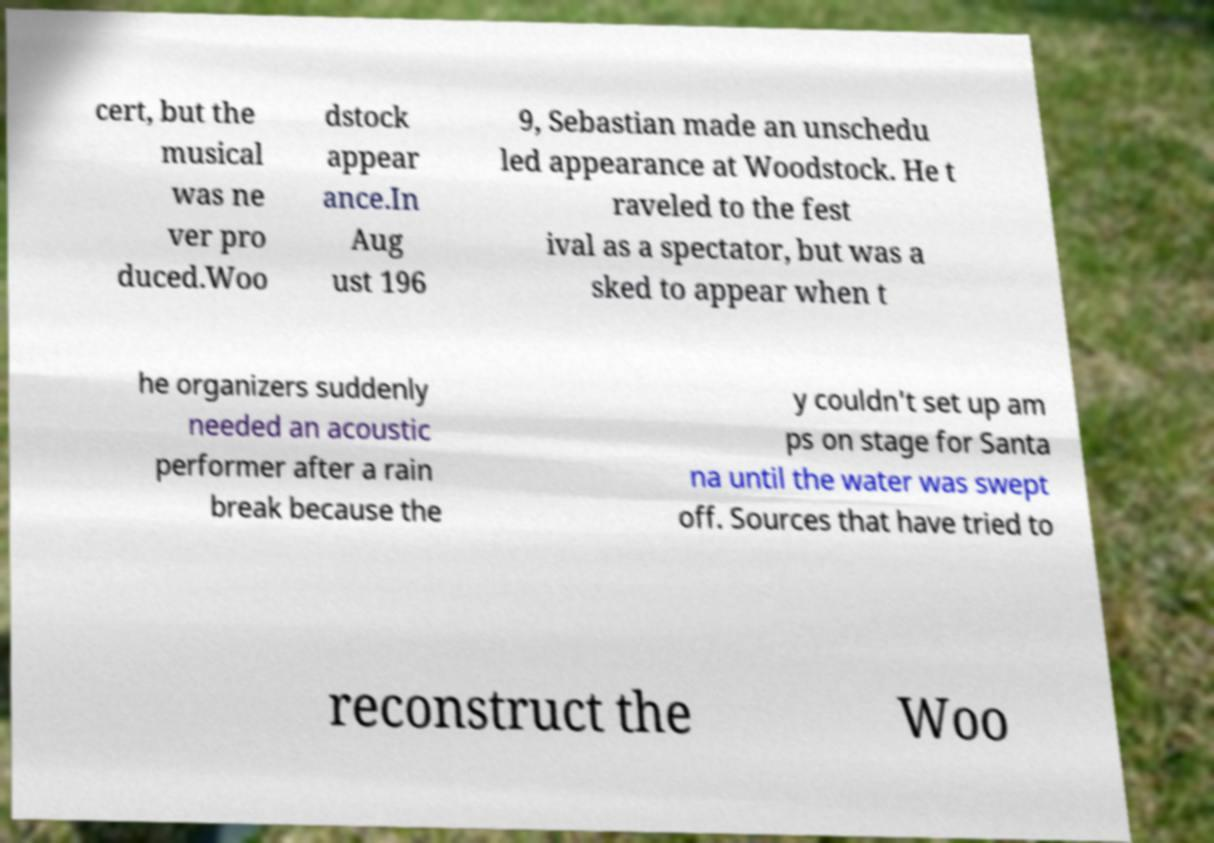Can you accurately transcribe the text from the provided image for me? cert, but the musical was ne ver pro duced.Woo dstock appear ance.In Aug ust 196 9, Sebastian made an unschedu led appearance at Woodstock. He t raveled to the fest ival as a spectator, but was a sked to appear when t he organizers suddenly needed an acoustic performer after a rain break because the y couldn't set up am ps on stage for Santa na until the water was swept off. Sources that have tried to reconstruct the Woo 